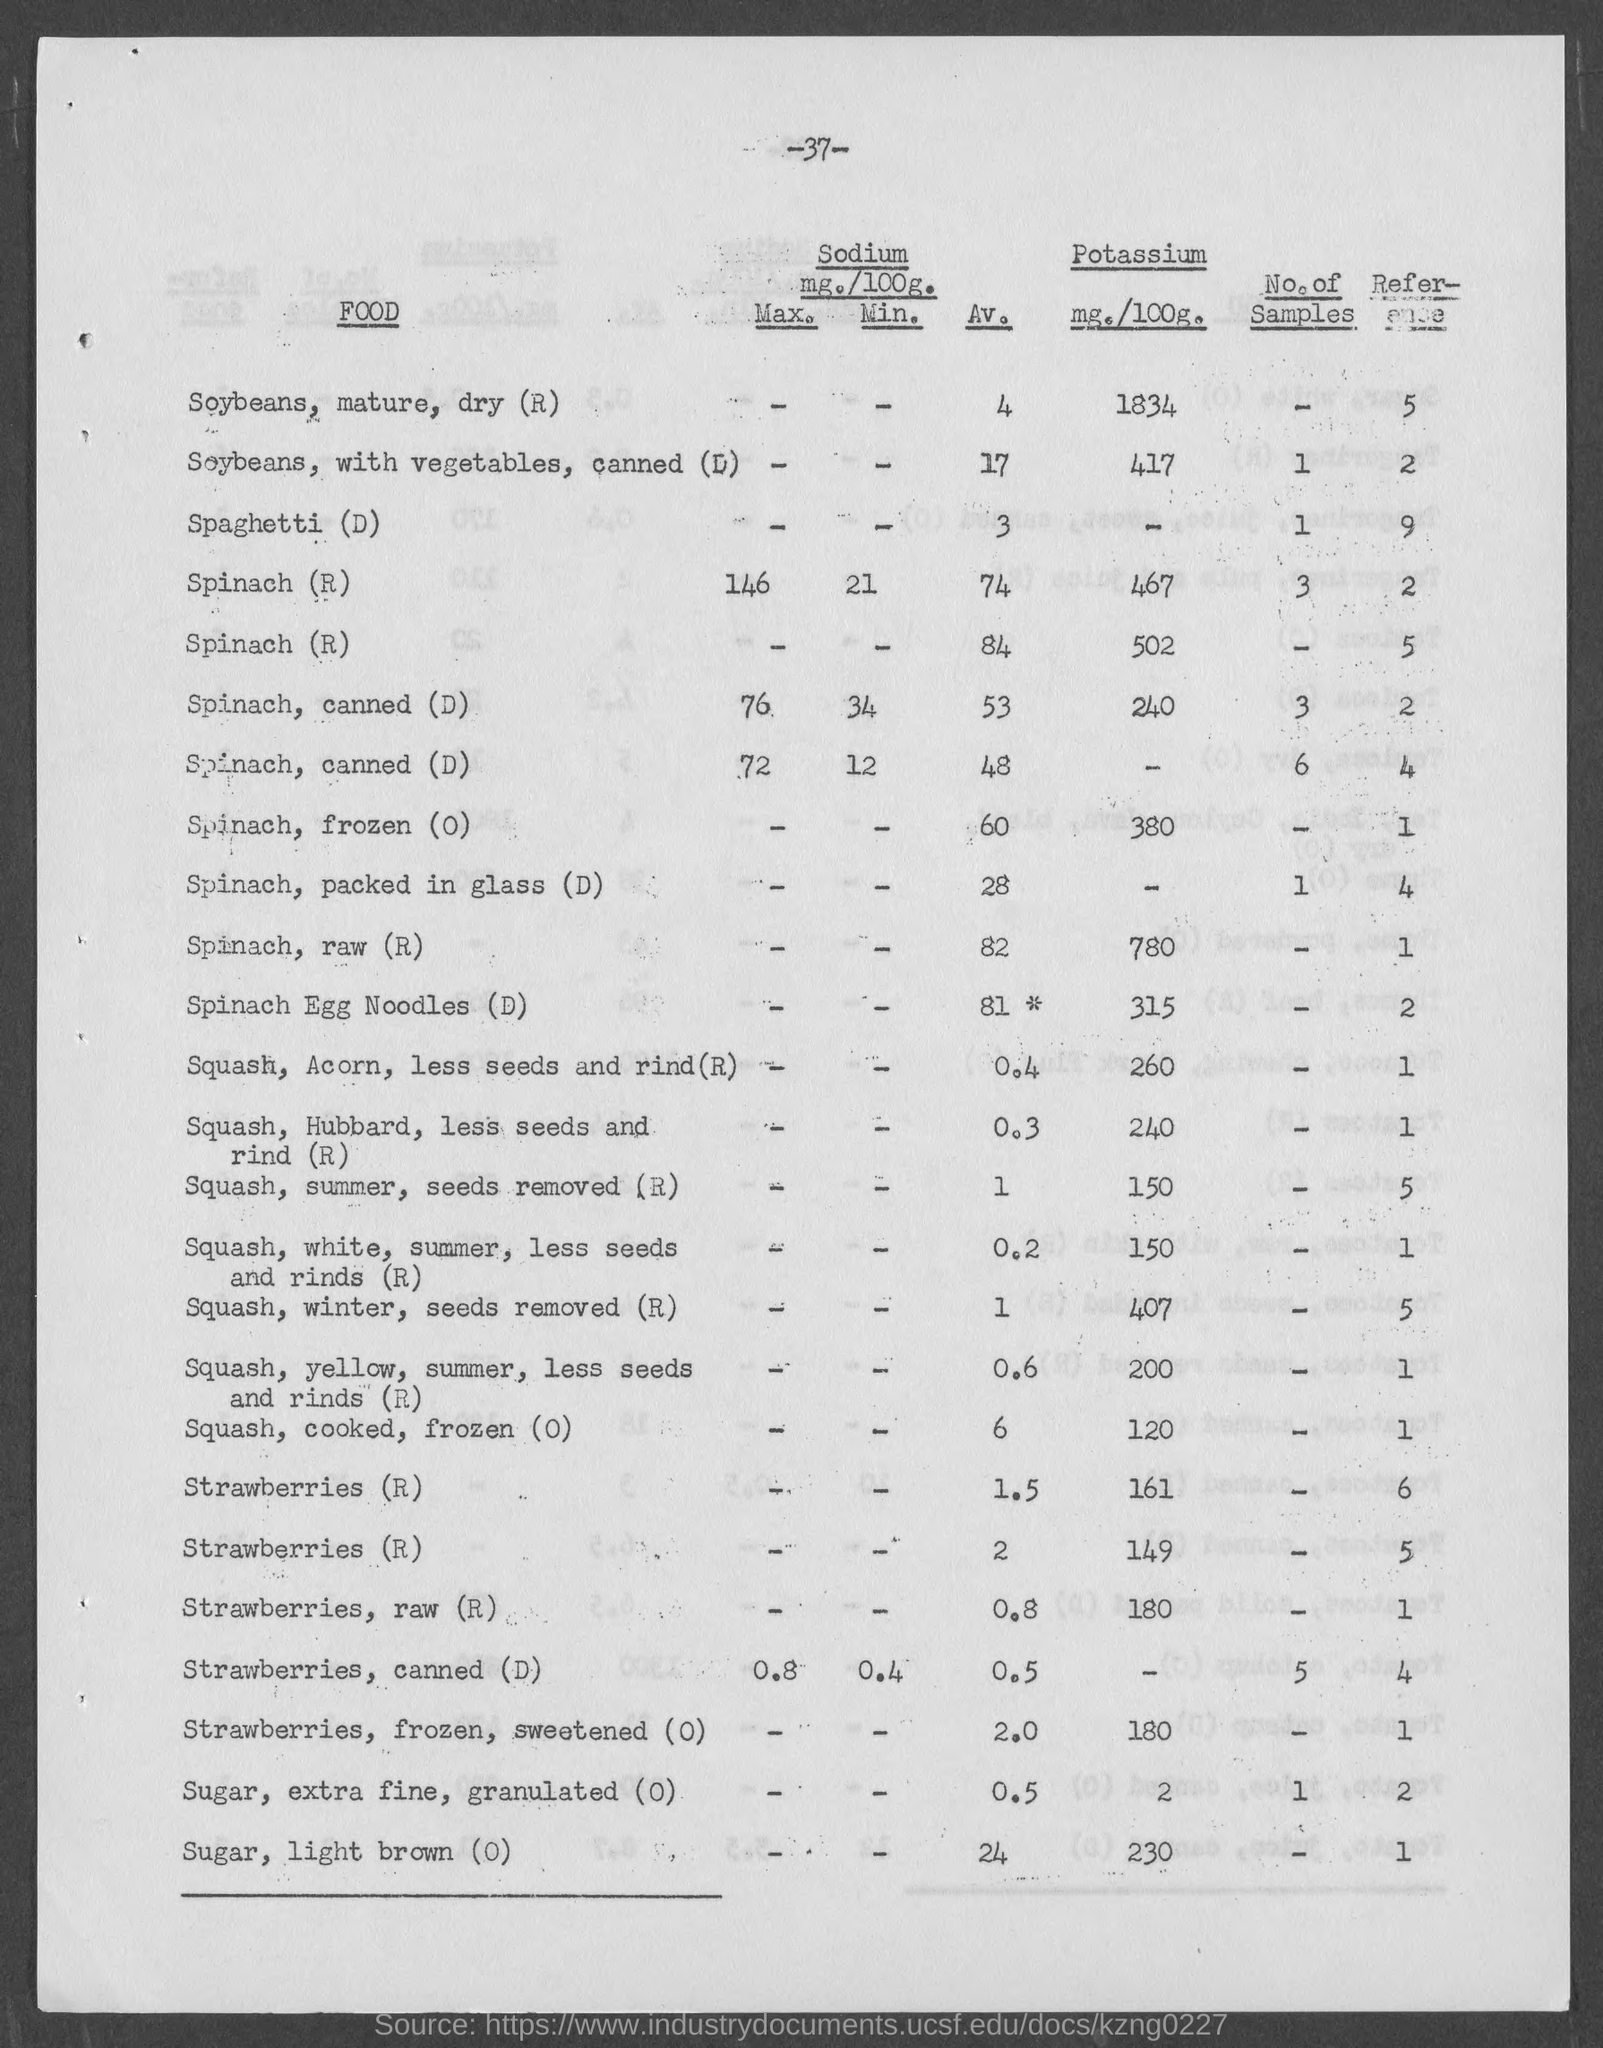Highlight a few significant elements in this photo. The amount of Potassium in 100 grams of light brown sugar is [230]. The number at the top of the page is -37-. The amount of Potassium in sugar, extra fine, granulated is 2 mg./100g. The amount of Potassium in Spinach and egg noodles is 315 mg per 100 grams. The potassium content of winter squash, with the seeds removed, is 407 milligrams per 100 grams. 